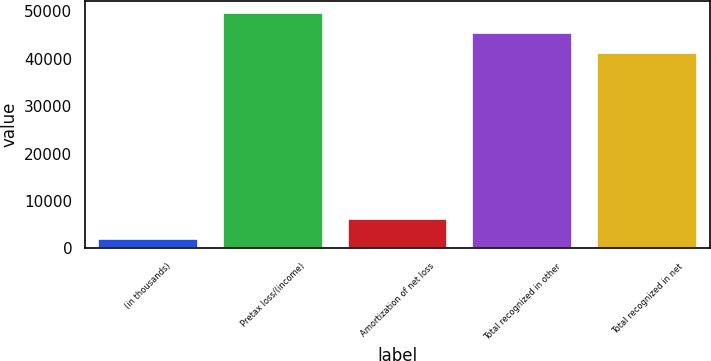<chart> <loc_0><loc_0><loc_500><loc_500><bar_chart><fcel>(in thousands)<fcel>Pretax loss/(income)<fcel>Amortization of net loss<fcel>Total recognized in other<fcel>Total recognized in net<nl><fcel>2014<fcel>49658<fcel>6228.5<fcel>45443.5<fcel>41229<nl></chart> 